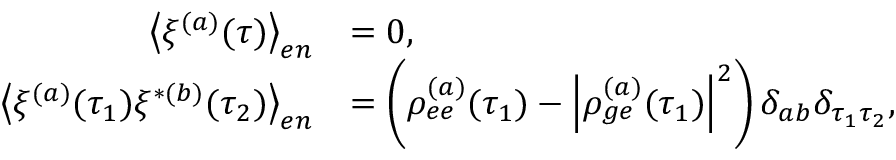Convert formula to latex. <formula><loc_0><loc_0><loc_500><loc_500>\begin{array} { r l } { \left \langle \xi ^ { ( a ) } ( \tau ) \right \rangle _ { e n } } & { = 0 , } \\ { \left \langle \xi ^ { ( a ) } ( \tau _ { 1 } ) \xi ^ { * ( b ) } ( \tau _ { 2 } ) \right \rangle _ { e n } } & { = \left ( \rho _ { e e } ^ { ( a ) } ( \tau _ { 1 } ) - \left | \rho _ { g e } ^ { ( a ) } ( \tau _ { 1 } ) \right | ^ { 2 } \right ) \delta _ { a b } \delta _ { \tau _ { 1 } \tau _ { 2 } } , } \end{array}</formula> 